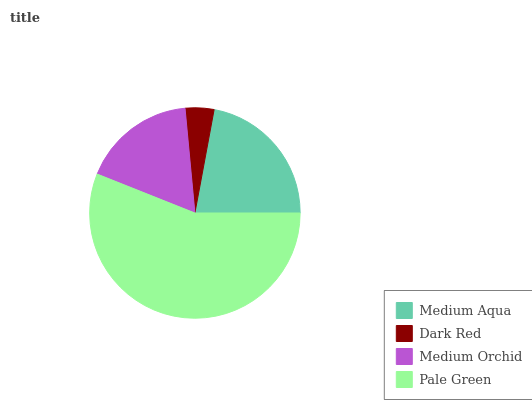Is Dark Red the minimum?
Answer yes or no. Yes. Is Pale Green the maximum?
Answer yes or no. Yes. Is Medium Orchid the minimum?
Answer yes or no. No. Is Medium Orchid the maximum?
Answer yes or no. No. Is Medium Orchid greater than Dark Red?
Answer yes or no. Yes. Is Dark Red less than Medium Orchid?
Answer yes or no. Yes. Is Dark Red greater than Medium Orchid?
Answer yes or no. No. Is Medium Orchid less than Dark Red?
Answer yes or no. No. Is Medium Aqua the high median?
Answer yes or no. Yes. Is Medium Orchid the low median?
Answer yes or no. Yes. Is Pale Green the high median?
Answer yes or no. No. Is Pale Green the low median?
Answer yes or no. No. 